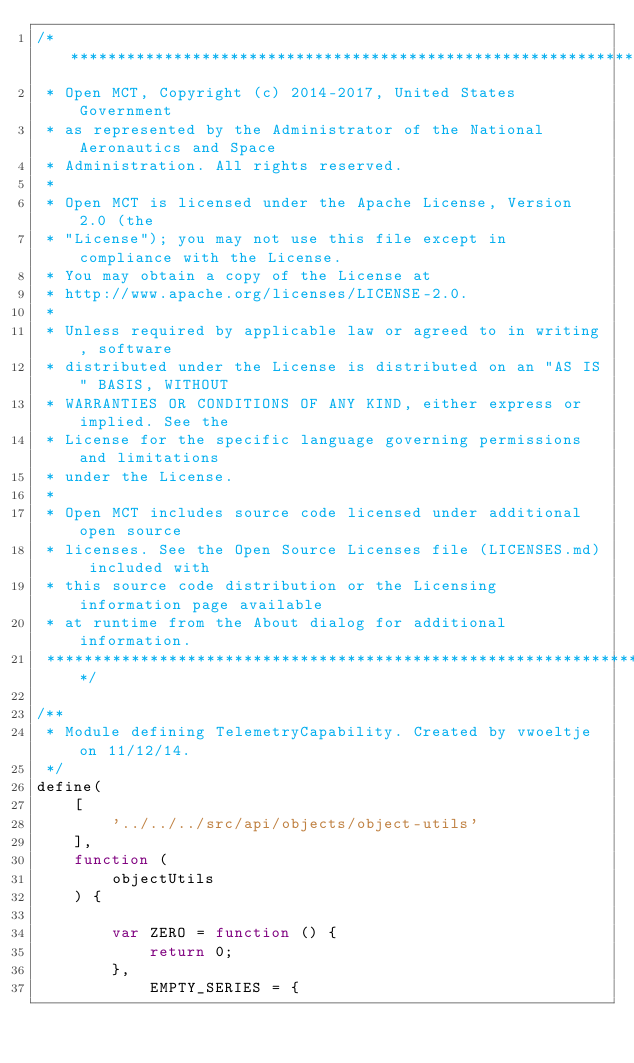<code> <loc_0><loc_0><loc_500><loc_500><_JavaScript_>/*****************************************************************************
 * Open MCT, Copyright (c) 2014-2017, United States Government
 * as represented by the Administrator of the National Aeronautics and Space
 * Administration. All rights reserved.
 *
 * Open MCT is licensed under the Apache License, Version 2.0 (the
 * "License"); you may not use this file except in compliance with the License.
 * You may obtain a copy of the License at
 * http://www.apache.org/licenses/LICENSE-2.0.
 *
 * Unless required by applicable law or agreed to in writing, software
 * distributed under the License is distributed on an "AS IS" BASIS, WITHOUT
 * WARRANTIES OR CONDITIONS OF ANY KIND, either express or implied. See the
 * License for the specific language governing permissions and limitations
 * under the License.
 *
 * Open MCT includes source code licensed under additional open source
 * licenses. See the Open Source Licenses file (LICENSES.md) included with
 * this source code distribution or the Licensing information page available
 * at runtime from the About dialog for additional information.
 *****************************************************************************/

/**
 * Module defining TelemetryCapability. Created by vwoeltje on 11/12/14.
 */
define(
    [
        '../../../src/api/objects/object-utils'
    ],
    function (
        objectUtils
    ) {

        var ZERO = function () {
            return 0;
        },
            EMPTY_SERIES = {</code> 